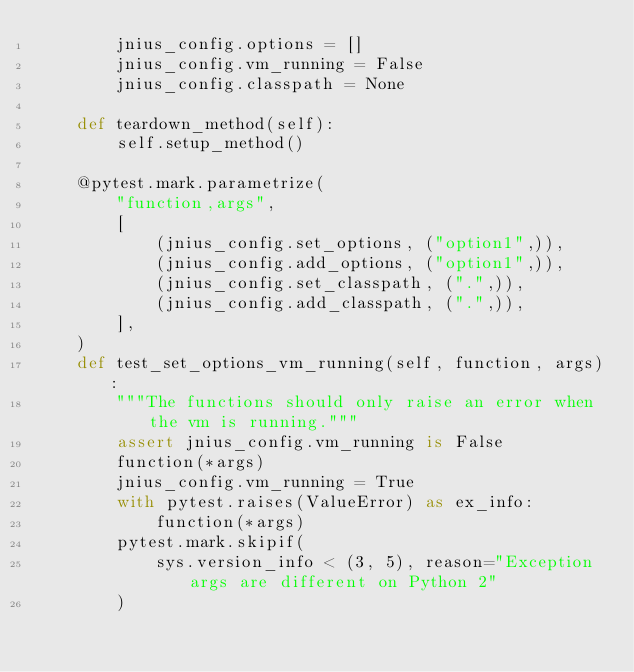Convert code to text. <code><loc_0><loc_0><loc_500><loc_500><_Python_>        jnius_config.options = []
        jnius_config.vm_running = False
        jnius_config.classpath = None

    def teardown_method(self):
        self.setup_method()

    @pytest.mark.parametrize(
        "function,args",
        [
            (jnius_config.set_options, ("option1",)),
            (jnius_config.add_options, ("option1",)),
            (jnius_config.set_classpath, (".",)),
            (jnius_config.add_classpath, (".",)),
        ],
    )
    def test_set_options_vm_running(self, function, args):
        """The functions should only raise an error when the vm is running."""
        assert jnius_config.vm_running is False
        function(*args)
        jnius_config.vm_running = True
        with pytest.raises(ValueError) as ex_info:
            function(*args)
        pytest.mark.skipif(
            sys.version_info < (3, 5), reason="Exception args are different on Python 2"
        )</code> 